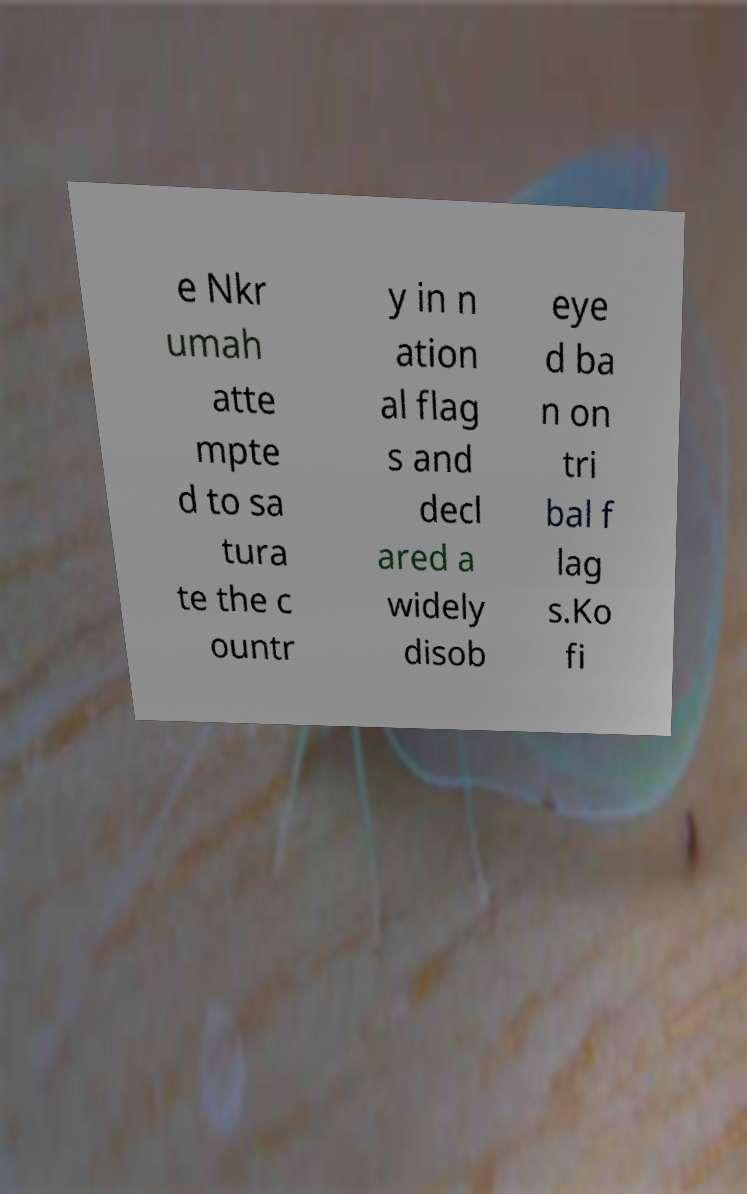Can you read and provide the text displayed in the image?This photo seems to have some interesting text. Can you extract and type it out for me? e Nkr umah atte mpte d to sa tura te the c ountr y in n ation al flag s and decl ared a widely disob eye d ba n on tri bal f lag s.Ko fi 